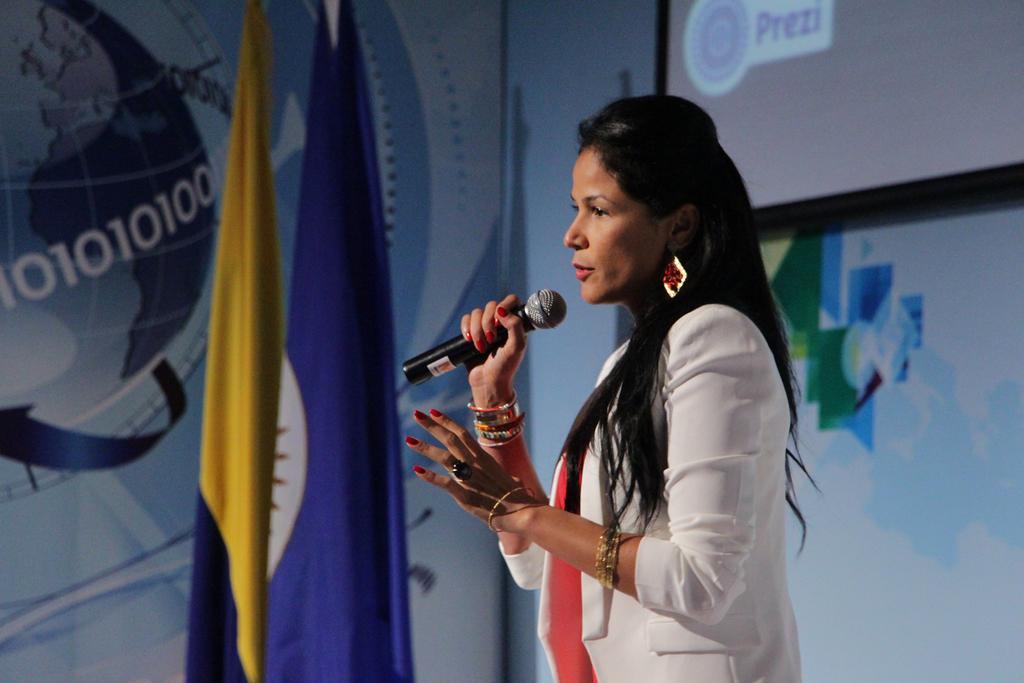In one or two sentences, can you explain what this image depicts? In the middle of the image a woman standing and holding a microphone. Top right side of the image there is a screen. In the middle of the image there is a flag. Behind the flag there is a banner. 